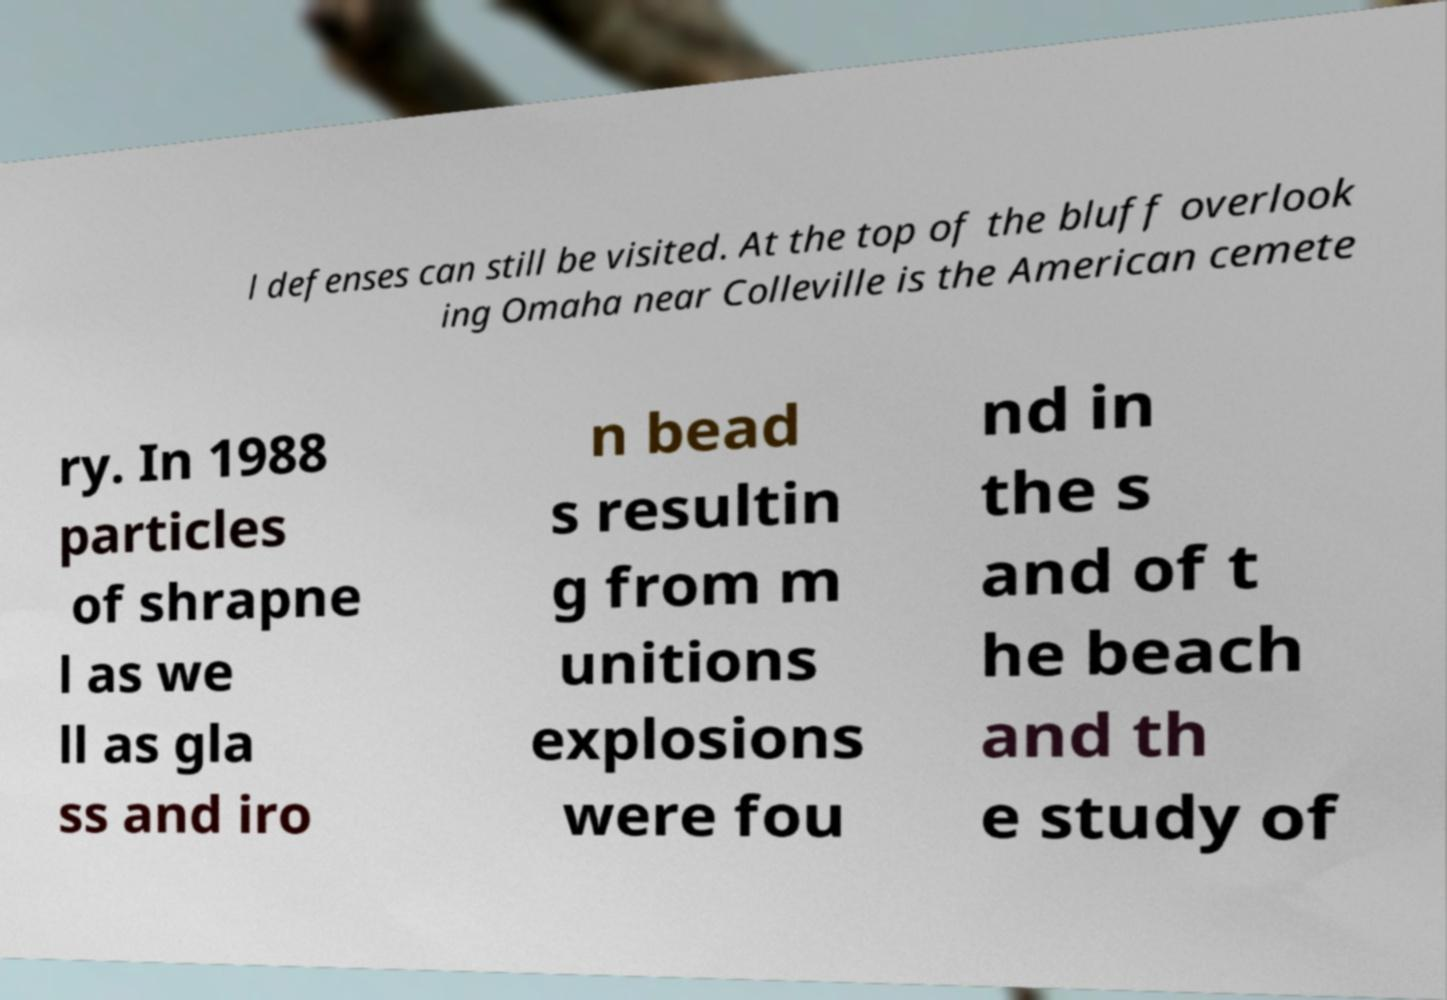There's text embedded in this image that I need extracted. Can you transcribe it verbatim? l defenses can still be visited. At the top of the bluff overlook ing Omaha near Colleville is the American cemete ry. In 1988 particles of shrapne l as we ll as gla ss and iro n bead s resultin g from m unitions explosions were fou nd in the s and of t he beach and th e study of 